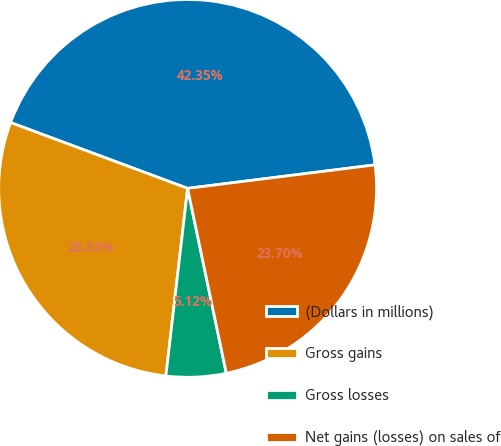<chart> <loc_0><loc_0><loc_500><loc_500><pie_chart><fcel>(Dollars in millions)<fcel>Gross gains<fcel>Gross losses<fcel>Net gains (losses) on sales of<nl><fcel>42.35%<fcel>28.83%<fcel>5.12%<fcel>23.7%<nl></chart> 